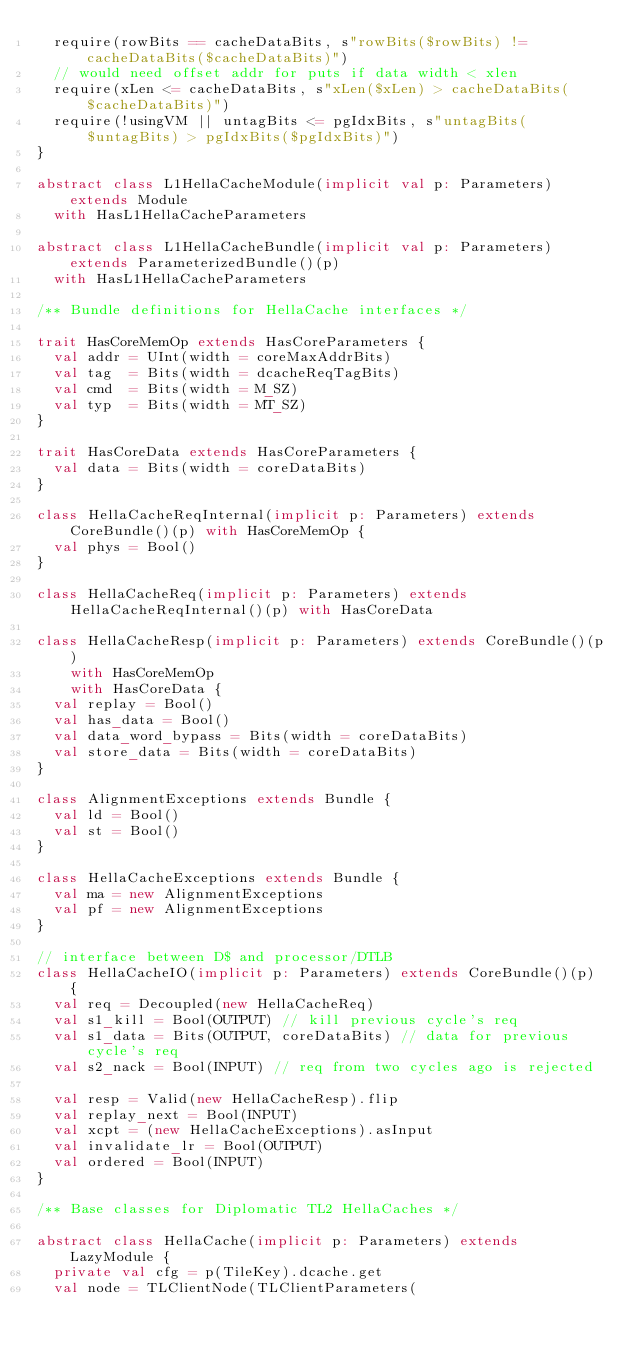<code> <loc_0><loc_0><loc_500><loc_500><_Scala_>  require(rowBits == cacheDataBits, s"rowBits($rowBits) != cacheDataBits($cacheDataBits)") 
  // would need offset addr for puts if data width < xlen
  require(xLen <= cacheDataBits, s"xLen($xLen) > cacheDataBits($cacheDataBits)")
  require(!usingVM || untagBits <= pgIdxBits, s"untagBits($untagBits) > pgIdxBits($pgIdxBits)")
}

abstract class L1HellaCacheModule(implicit val p: Parameters) extends Module
  with HasL1HellaCacheParameters

abstract class L1HellaCacheBundle(implicit val p: Parameters) extends ParameterizedBundle()(p)
  with HasL1HellaCacheParameters

/** Bundle definitions for HellaCache interfaces */

trait HasCoreMemOp extends HasCoreParameters {
  val addr = UInt(width = coreMaxAddrBits)
  val tag  = Bits(width = dcacheReqTagBits)
  val cmd  = Bits(width = M_SZ)
  val typ  = Bits(width = MT_SZ)
}

trait HasCoreData extends HasCoreParameters {
  val data = Bits(width = coreDataBits)
}

class HellaCacheReqInternal(implicit p: Parameters) extends CoreBundle()(p) with HasCoreMemOp {
  val phys = Bool()
}

class HellaCacheReq(implicit p: Parameters) extends HellaCacheReqInternal()(p) with HasCoreData

class HellaCacheResp(implicit p: Parameters) extends CoreBundle()(p)
    with HasCoreMemOp
    with HasCoreData {
  val replay = Bool()
  val has_data = Bool()
  val data_word_bypass = Bits(width = coreDataBits)
  val store_data = Bits(width = coreDataBits)
}

class AlignmentExceptions extends Bundle {
  val ld = Bool()
  val st = Bool()
}

class HellaCacheExceptions extends Bundle {
  val ma = new AlignmentExceptions
  val pf = new AlignmentExceptions
}

// interface between D$ and processor/DTLB
class HellaCacheIO(implicit p: Parameters) extends CoreBundle()(p) {
  val req = Decoupled(new HellaCacheReq)
  val s1_kill = Bool(OUTPUT) // kill previous cycle's req
  val s1_data = Bits(OUTPUT, coreDataBits) // data for previous cycle's req
  val s2_nack = Bool(INPUT) // req from two cycles ago is rejected

  val resp = Valid(new HellaCacheResp).flip
  val replay_next = Bool(INPUT)
  val xcpt = (new HellaCacheExceptions).asInput
  val invalidate_lr = Bool(OUTPUT)
  val ordered = Bool(INPUT)
}

/** Base classes for Diplomatic TL2 HellaCaches */

abstract class HellaCache(implicit p: Parameters) extends LazyModule {
  private val cfg = p(TileKey).dcache.get
  val node = TLClientNode(TLClientParameters(</code> 